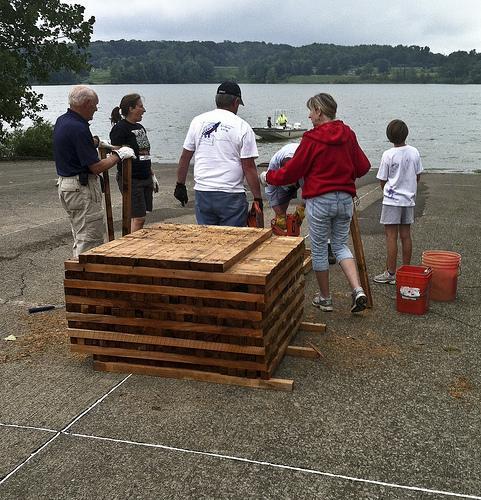How many people are in red?
Give a very brief answer. 1. 